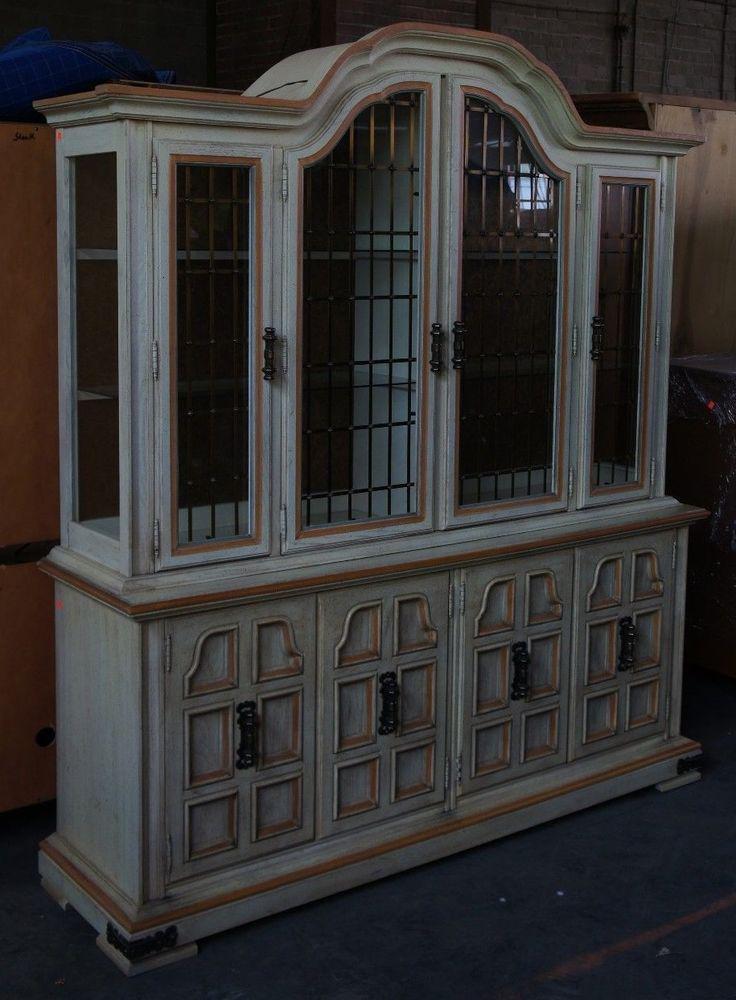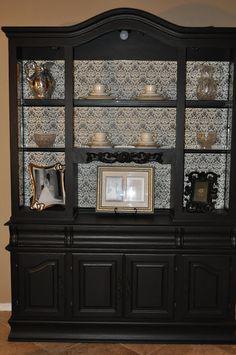The first image is the image on the left, the second image is the image on the right. For the images shown, is this caption "There is at least one item on top of the cabinet in the image on the left." true? Answer yes or no. No. 